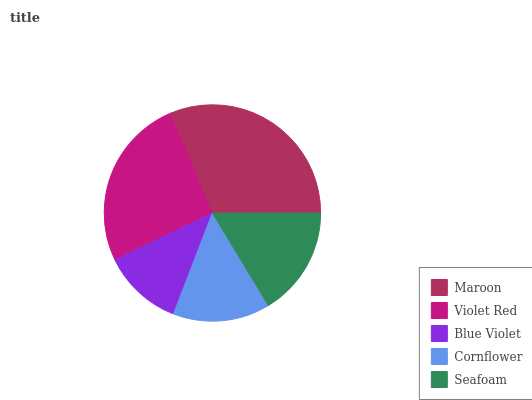Is Blue Violet the minimum?
Answer yes or no. Yes. Is Maroon the maximum?
Answer yes or no. Yes. Is Violet Red the minimum?
Answer yes or no. No. Is Violet Red the maximum?
Answer yes or no. No. Is Maroon greater than Violet Red?
Answer yes or no. Yes. Is Violet Red less than Maroon?
Answer yes or no. Yes. Is Violet Red greater than Maroon?
Answer yes or no. No. Is Maroon less than Violet Red?
Answer yes or no. No. Is Seafoam the high median?
Answer yes or no. Yes. Is Seafoam the low median?
Answer yes or no. Yes. Is Maroon the high median?
Answer yes or no. No. Is Blue Violet the low median?
Answer yes or no. No. 